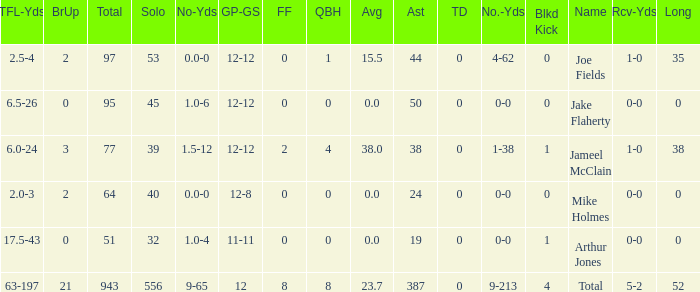How many tackle assists for the player who averages 23.7? 387.0. 